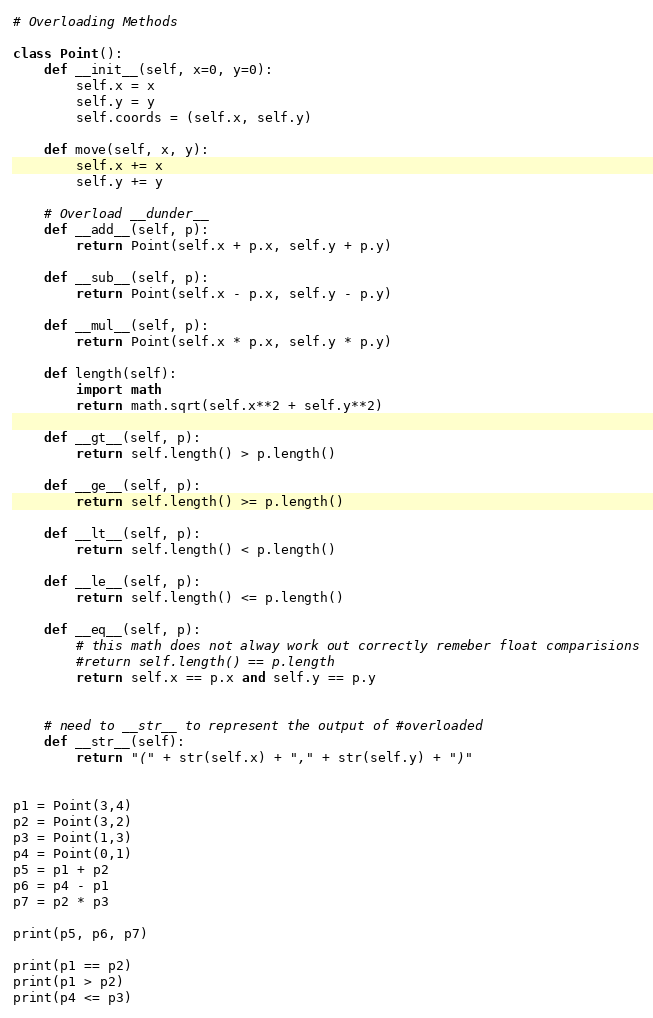Convert code to text. <code><loc_0><loc_0><loc_500><loc_500><_Python_># Overloading Methods

class Point():
    def __init__(self, x=0, y=0):
        self.x = x
        self.y = y
        self.coords = (self.x, self.y)

    def move(self, x, y):
        self.x += x
        self.y += y

    # Overload __dunder__
    def __add__(self, p):
        return Point(self.x + p.x, self.y + p.y)

    def __sub__(self, p):
        return Point(self.x - p.x, self.y - p.y)
    
    def __mul__(self, p):
        return Point(self.x * p.x, self.y * p.y)

    def length(self):
        import math
        return math.sqrt(self.x**2 + self.y**2)

    def __gt__(self, p):
        return self.length() > p.length()

    def __ge__(self, p):
        return self.length() >= p.length()
    
    def __lt__(self, p):
        return self.length() < p.length()

    def __le__(self, p):
        return self.length() <= p.length()

    def __eq__(self, p):
        # this math does not alway work out correctly remeber float comparisions
        #return self.length() == p.length
        return self.x == p.x and self.y == p.y


    # need to __str__ to represent the output of #overloaded
    def __str__(self):
        return "(" + str(self.x) + "," + str(self.y) + ")"


p1 = Point(3,4)
p2 = Point(3,2)
p3 = Point(1,3)
p4 = Point(0,1)
p5 = p1 + p2
p6 = p4 - p1
p7 = p2 * p3

print(p5, p6, p7)

print(p1 == p2)
print(p1 > p2)
print(p4 <= p3)
</code> 